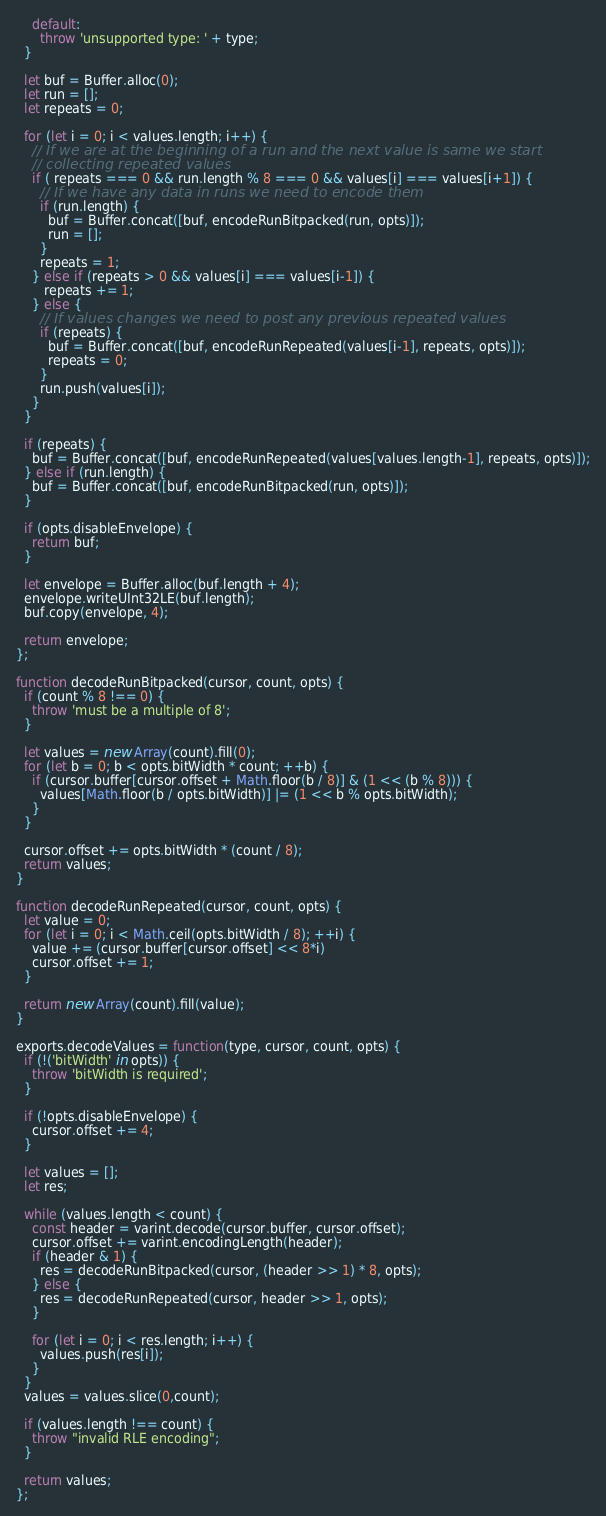Convert code to text. <code><loc_0><loc_0><loc_500><loc_500><_JavaScript_>    default:
      throw 'unsupported type: ' + type;
  }

  let buf = Buffer.alloc(0);
  let run = [];
  let repeats = 0;

  for (let i = 0; i < values.length; i++) {
    // If we are at the beginning of a run and the next value is same we start
    // collecting repeated values
    if ( repeats === 0 && run.length % 8 === 0 && values[i] === values[i+1]) {
      // If we have any data in runs we need to encode them
      if (run.length) {
        buf = Buffer.concat([buf, encodeRunBitpacked(run, opts)]);
        run = [];
      }
      repeats = 1;
    } else if (repeats > 0 && values[i] === values[i-1]) {
       repeats += 1;
    } else {
      // If values changes we need to post any previous repeated values
      if (repeats) {
        buf = Buffer.concat([buf, encodeRunRepeated(values[i-1], repeats, opts)]);
        repeats = 0;
      }
      run.push(values[i]);
    }
  }

  if (repeats) {
    buf = Buffer.concat([buf, encodeRunRepeated(values[values.length-1], repeats, opts)]);
  } else if (run.length) {
    buf = Buffer.concat([buf, encodeRunBitpacked(run, opts)]);
  }

  if (opts.disableEnvelope) {
    return buf;
  }

  let envelope = Buffer.alloc(buf.length + 4);
  envelope.writeUInt32LE(buf.length);
  buf.copy(envelope, 4);

  return envelope;
};

function decodeRunBitpacked(cursor, count, opts) {
  if (count % 8 !== 0) {
    throw 'must be a multiple of 8';
  }

  let values = new Array(count).fill(0);
  for (let b = 0; b < opts.bitWidth * count; ++b) {
    if (cursor.buffer[cursor.offset + Math.floor(b / 8)] & (1 << (b % 8))) {
      values[Math.floor(b / opts.bitWidth)] |= (1 << b % opts.bitWidth);
    }
  }

  cursor.offset += opts.bitWidth * (count / 8);
  return values;
}

function decodeRunRepeated(cursor, count, opts) {
  let value = 0;
  for (let i = 0; i < Math.ceil(opts.bitWidth / 8); ++i) {
    value += (cursor.buffer[cursor.offset] << 8*i)
    cursor.offset += 1;
  }

  return new Array(count).fill(value);
}

exports.decodeValues = function(type, cursor, count, opts) {
  if (!('bitWidth' in opts)) {
    throw 'bitWidth is required';
  }

  if (!opts.disableEnvelope) {
    cursor.offset += 4;
  }

  let values = [];
  let res;

  while (values.length < count) {
    const header = varint.decode(cursor.buffer, cursor.offset);
    cursor.offset += varint.encodingLength(header);
    if (header & 1) {
      res = decodeRunBitpacked(cursor, (header >> 1) * 8, opts);
    } else {
      res = decodeRunRepeated(cursor, header >> 1, opts);
    }

    for (let i = 0; i < res.length; i++) {
      values.push(res[i]);
    }
  }
  values = values.slice(0,count);

  if (values.length !== count) {
    throw "invalid RLE encoding";
  }

  return values;
};
</code> 